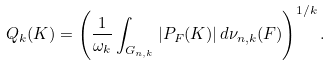Convert formula to latex. <formula><loc_0><loc_0><loc_500><loc_500>Q _ { k } ( K ) = \left ( \frac { 1 } { \omega _ { k } } \int _ { G _ { n , k } } | P _ { F } ( K ) | \, d \nu _ { n , k } ( F ) \right ) ^ { 1 / k } .</formula> 